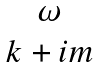<formula> <loc_0><loc_0><loc_500><loc_500>\begin{matrix} \omega \\ k + i m \end{matrix}</formula> 